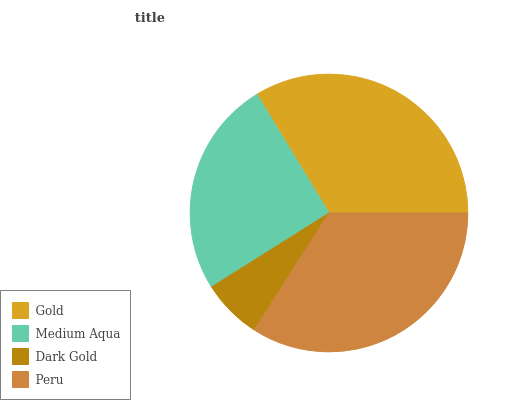Is Dark Gold the minimum?
Answer yes or no. Yes. Is Peru the maximum?
Answer yes or no. Yes. Is Medium Aqua the minimum?
Answer yes or no. No. Is Medium Aqua the maximum?
Answer yes or no. No. Is Gold greater than Medium Aqua?
Answer yes or no. Yes. Is Medium Aqua less than Gold?
Answer yes or no. Yes. Is Medium Aqua greater than Gold?
Answer yes or no. No. Is Gold less than Medium Aqua?
Answer yes or no. No. Is Gold the high median?
Answer yes or no. Yes. Is Medium Aqua the low median?
Answer yes or no. Yes. Is Peru the high median?
Answer yes or no. No. Is Dark Gold the low median?
Answer yes or no. No. 